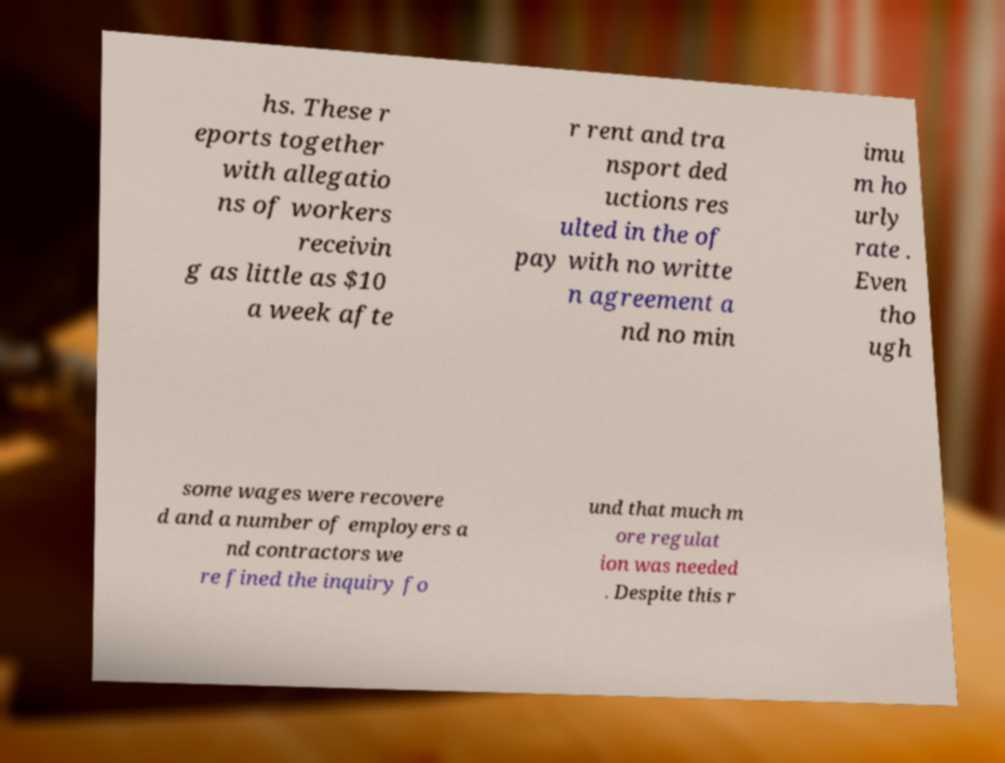I need the written content from this picture converted into text. Can you do that? hs. These r eports together with allegatio ns of workers receivin g as little as $10 a week afte r rent and tra nsport ded uctions res ulted in the of pay with no writte n agreement a nd no min imu m ho urly rate . Even tho ugh some wages were recovere d and a number of employers a nd contractors we re fined the inquiry fo und that much m ore regulat ion was needed . Despite this r 